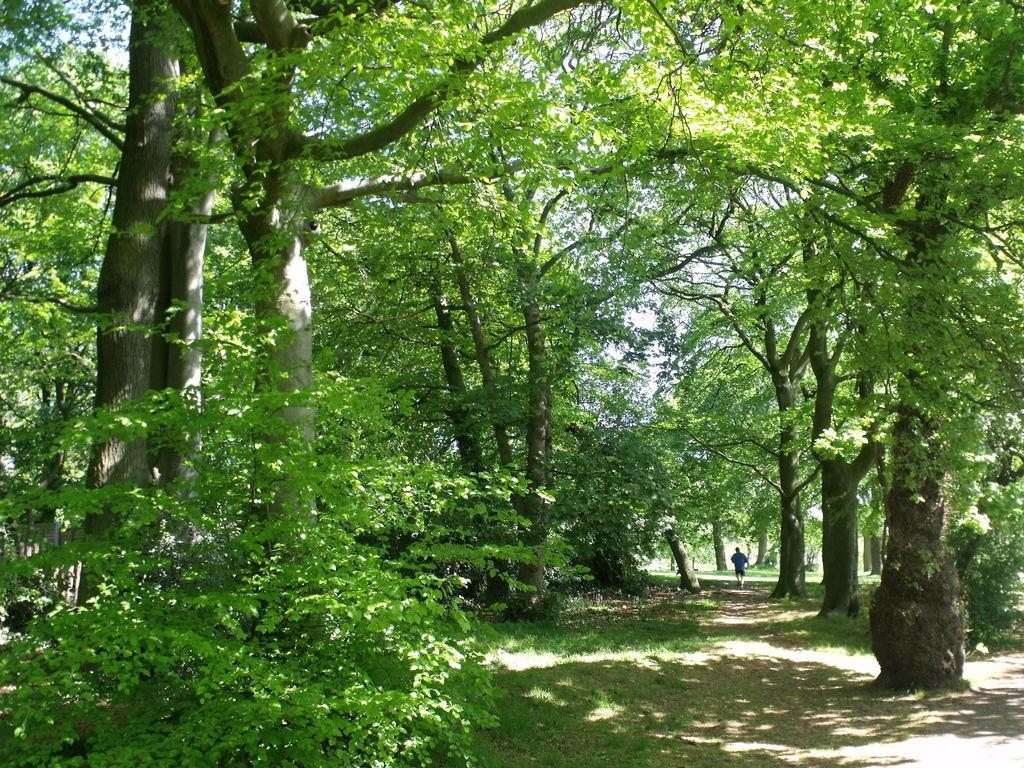What type of vegetation is present in the image? There are dense trees in the image. Is there any visible pathway in the image? Yes, there is a path visible between the trees. Can you describe the person in the image? There is a person walking through the path in the image. What type of van can be seen parked on the side of the path in the image? There is no van present in the image; it only features dense trees, a path, and a person walking through the path. 